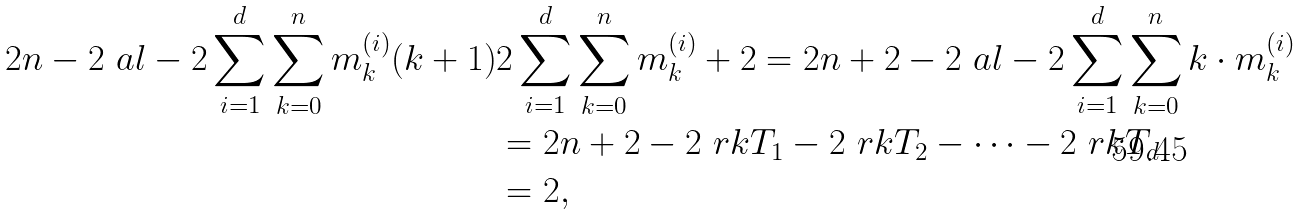<formula> <loc_0><loc_0><loc_500><loc_500>2 n - 2 \ a l - 2 \sum _ { i = 1 } ^ { d } \sum _ { k = 0 } ^ { n } m ^ { ( i ) } _ { k } ( k + 1 ) & 2 \sum _ { i = 1 } ^ { d } \sum _ { k = 0 } ^ { n } m ^ { ( i ) } _ { k } + 2 = 2 n + 2 - 2 \ a l - 2 \sum _ { i = 1 } ^ { d } \sum _ { k = 0 } ^ { n } k \cdot m ^ { ( i ) } _ { k } \\ & = 2 n + 2 - 2 \ r k T _ { 1 } - 2 \ r k T _ { 2 } - \dots - 2 \ r k T _ { d } \\ & = 2 ,</formula> 